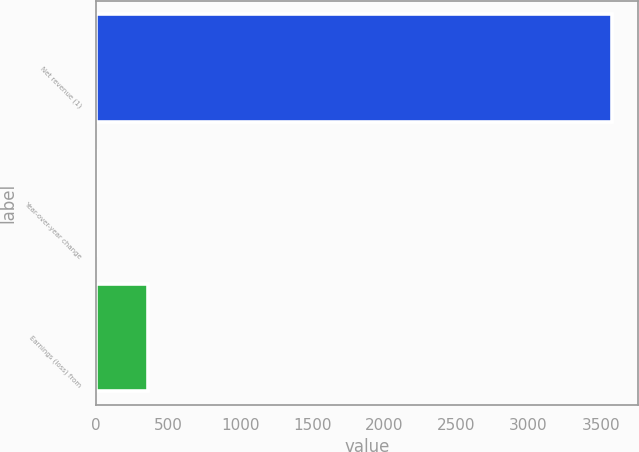Convert chart to OTSL. <chart><loc_0><loc_0><loc_500><loc_500><bar_chart><fcel>Net revenue (1)<fcel>Year-over-year change<fcel>Earnings (loss) from<nl><fcel>3581<fcel>2.5<fcel>360.35<nl></chart> 